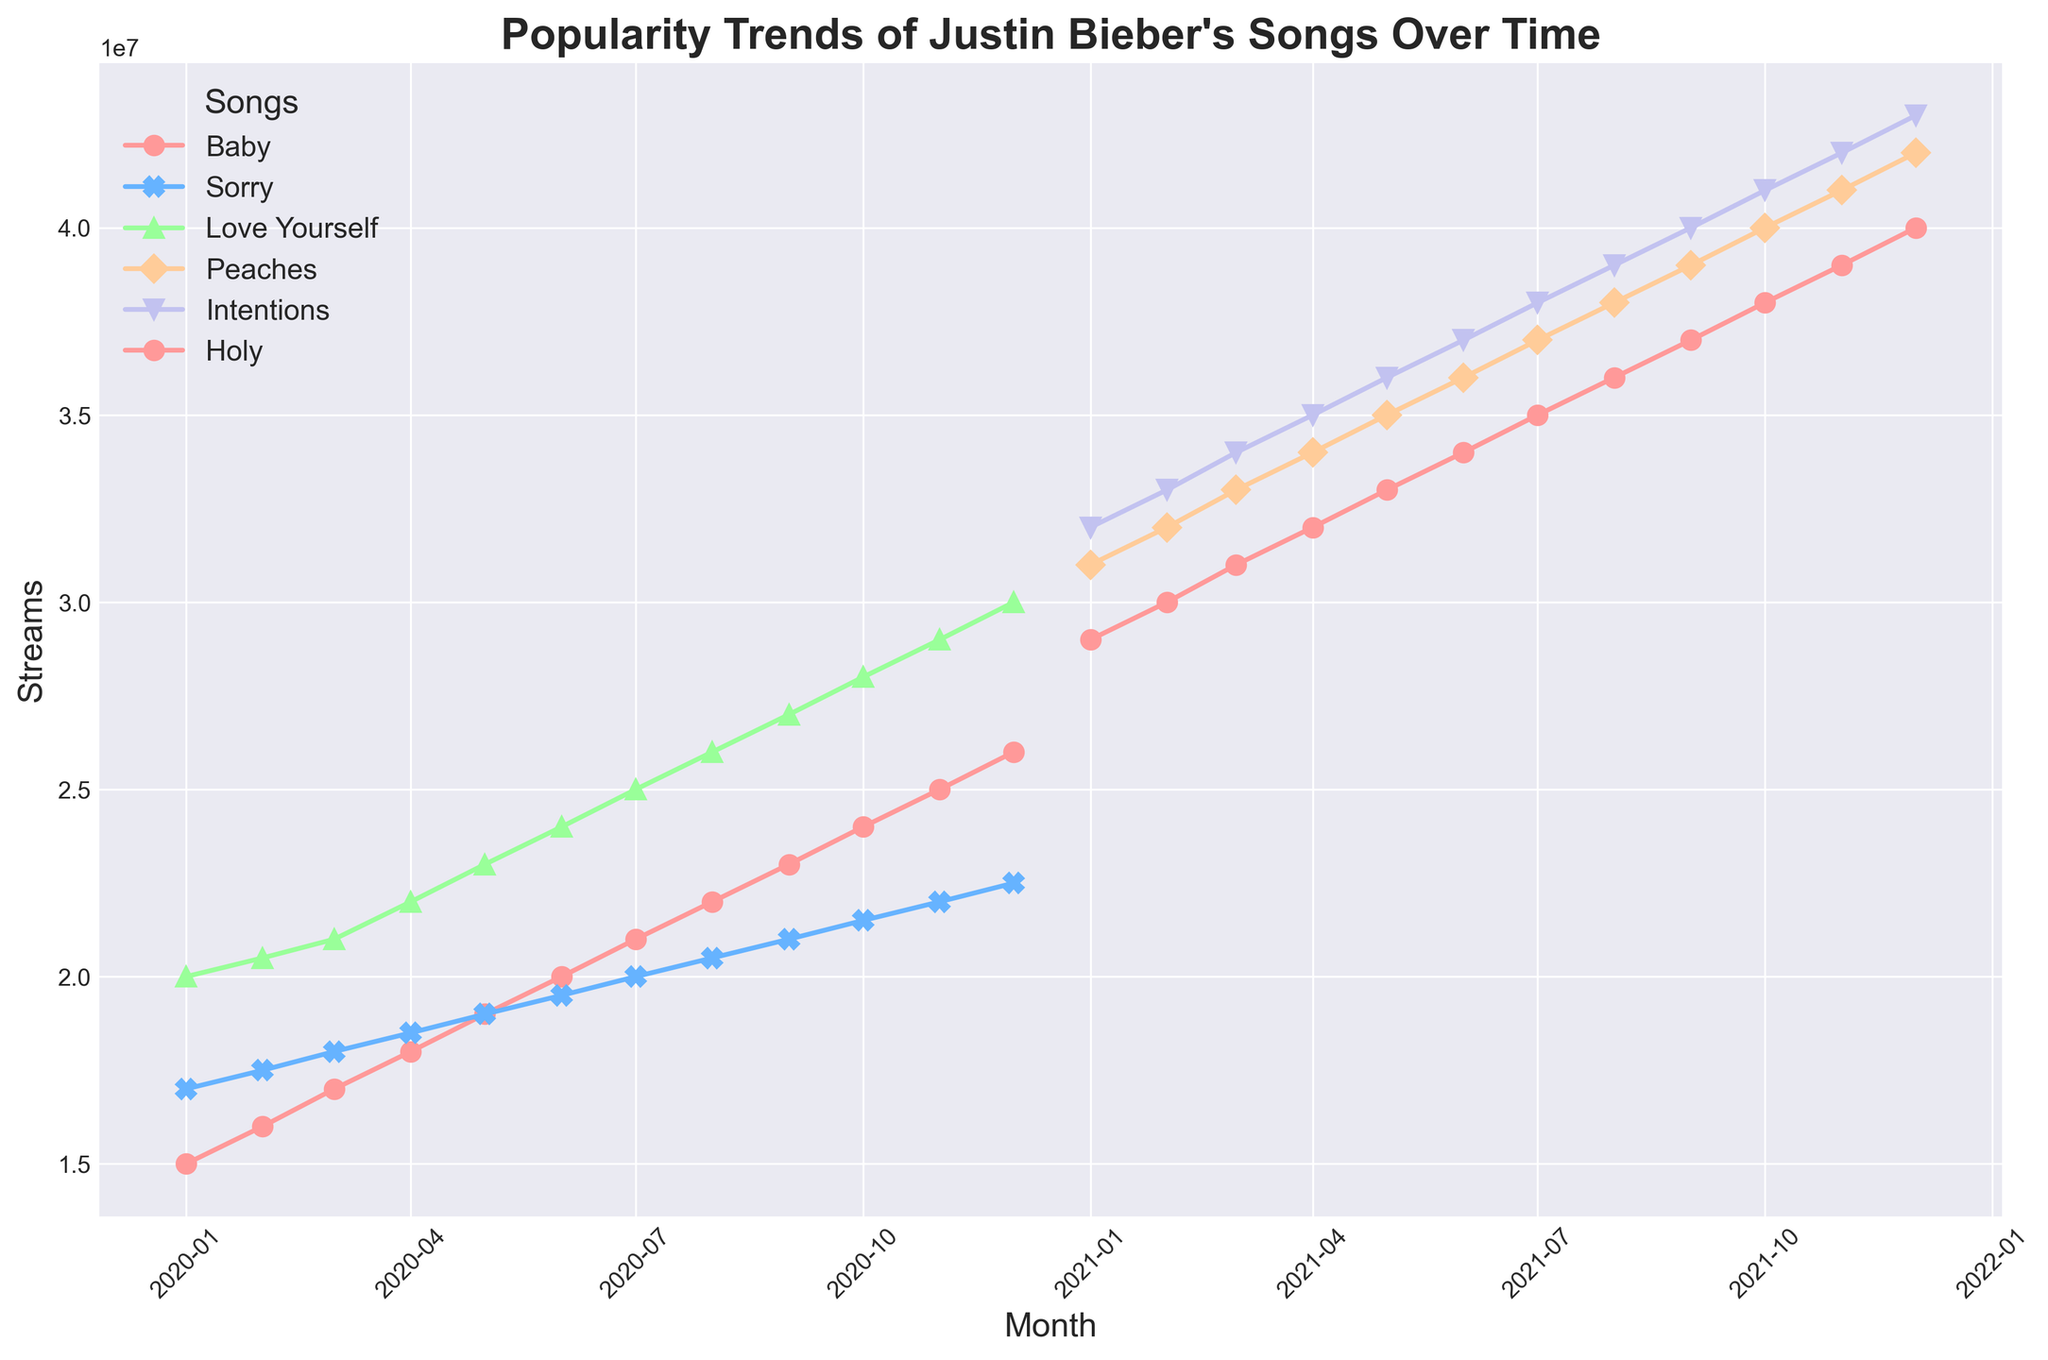Which song has the maximum number of streams in December 2021? From the chart, look for the data points corresponding to December 2021 and compare the stream numbers for each song. Peaches has the highest stream with 42,000,000 streams.
Answer: Peaches Which song showed the most consistent increase in streams over the period 2020-01 to 2021-12? Look at the slopes of the lines representing the songs. Love Yourself consistently increases from 20,000,000 in January 2020 to 30,000,000 in December 2020 without any drops. Similarly, Intentions consistently increases from January 2021 onwards. The gap between the lines indicates an increase.
Answer: Love Yourself Which song had the highest average monthly streams for the year 2021? Calculate the monthly streams for each song in 2021 and take the average: Peaches (37500000), Intentions (38500000), Holy (33500000). Intentions has the highest average.
Answer: Intentions Between which months did the streams for the song "Sorry" show the steepest upward trend? Identify the steepest incline for "Sorry." Between January 2020 (17,000,000) and December 2020 (22,500,000), the increase is 5,500,000 streams, which is the steepest increase for "Sorry."
Answer: January 2020 to December 2020 What is the difference in streams between 'Love Yourself' and 'Baby' in May 2020? Identify the number of streams for both songs in May 2020: Love Yourself (23,000,000) and Baby (19,000,000). Calculate the difference: 23,000,000 - 19,000,000 = 4,000,000.
Answer: 4,000,000 Which song had the steadiest growth after its introduction in 2021? Compare the lines for Peaches, Intentions, and Holy after January 2021. Intentions shows a steady increase every month without any dips.
Answer: Intentions How many months did it take for 'Intentions' to surpass 40 million streams? Check the stream numbers for 'Intentions' starting from January 2021 (32,000,000) and find the month when it first surpasses 40,000,000 streams, which is October 2021. It took 10 months (January to October).
Answer: 10 months By how much did the streams of 'Holy' increase from January 2021 to December 2021? Streams of 'Holy' in January 2021 were 29,000,000 and in December 2021 were 40,000,000. The increase is 40,000,000 - 29,000,000 = 11,000,000.
Answer: 11,000,000 